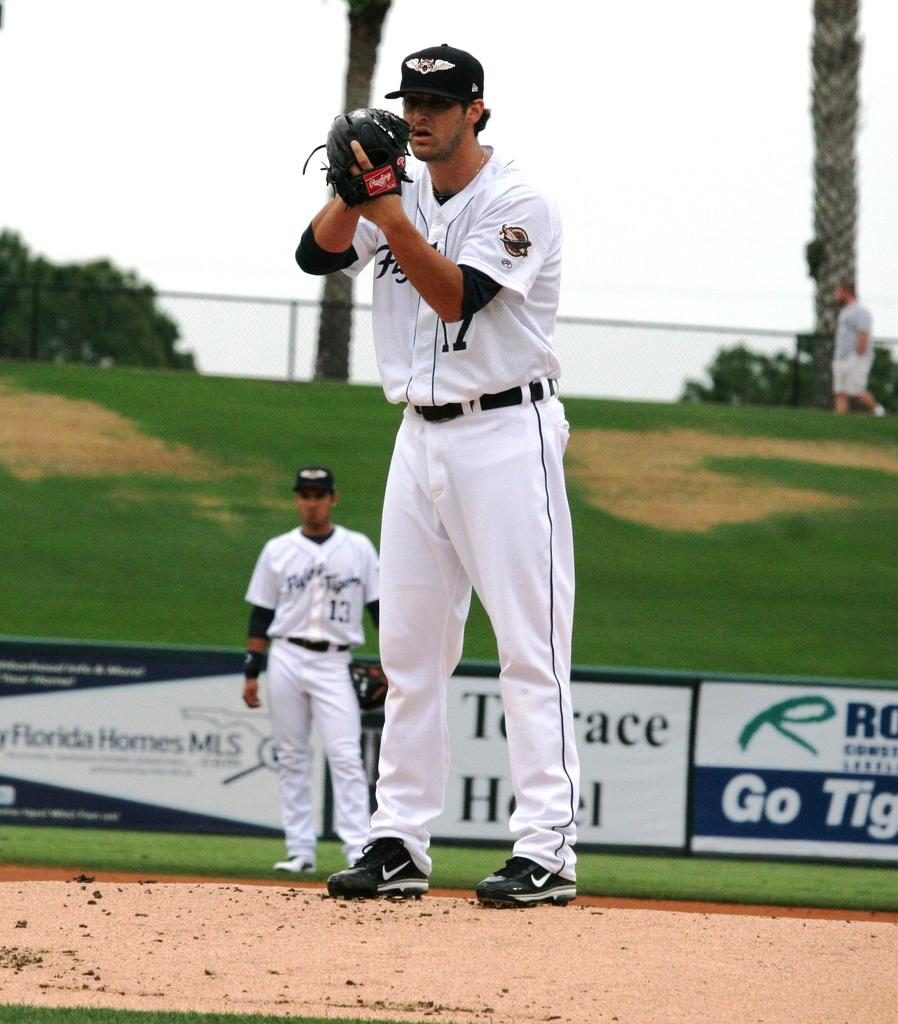<image>
Render a clear and concise summary of the photo. Player number 13 stands behind the pitcher on a baseball field. 